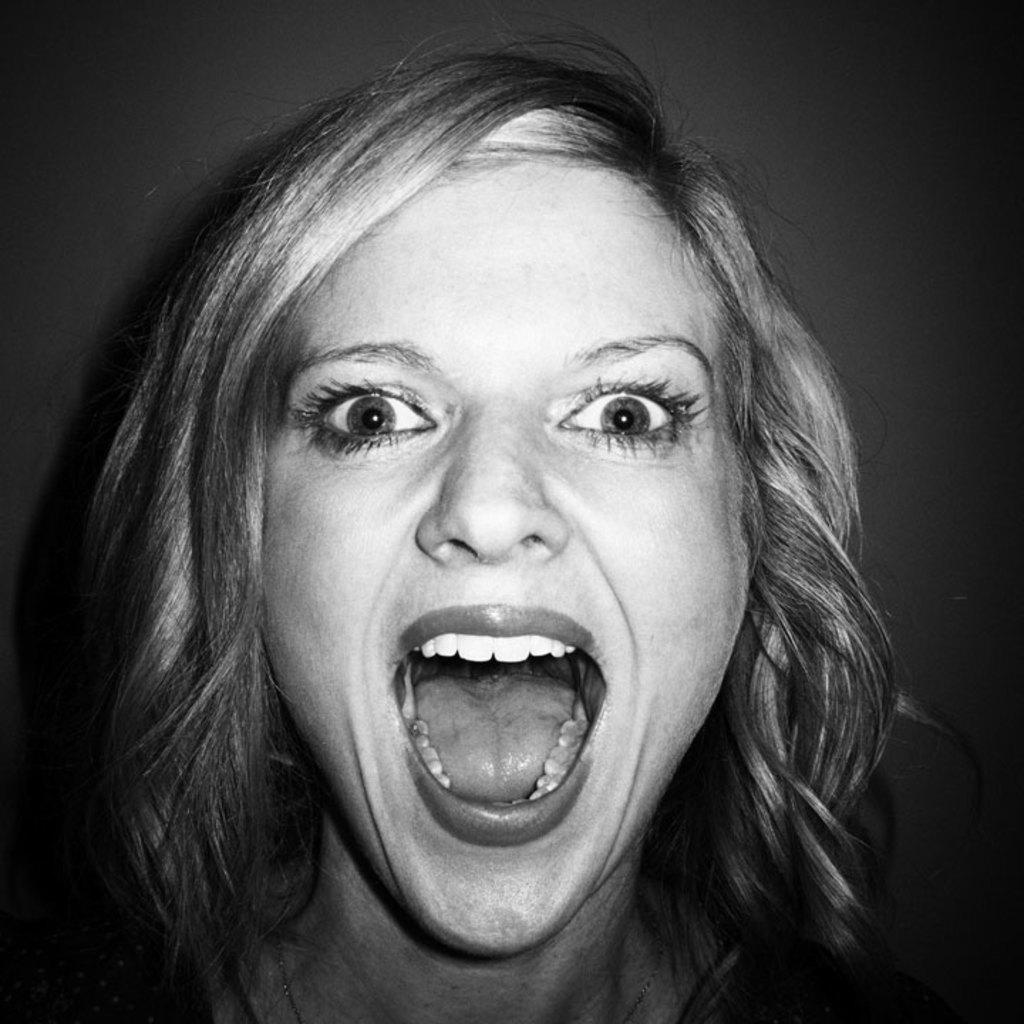Who is the main subject in the image? There is a woman in the image. What is the woman doing in the image? The woman is shouting. Can you describe the background of the image? The background of the image is blurred. What type of mask is the woman wearing in the image? There is no mask present in the image; the woman is not wearing one. What kind of art can be seen in the background of the image? There is no art visible in the image, as the background is blurred. 